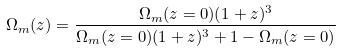<formula> <loc_0><loc_0><loc_500><loc_500>\Omega _ { m } ( z ) = \frac { \Omega _ { m } ( z = 0 ) ( 1 + z ) ^ { 3 } } { \Omega _ { m } ( z = 0 ) ( 1 + z ) ^ { 3 } + 1 - \Omega _ { m } ( z = 0 ) }</formula> 